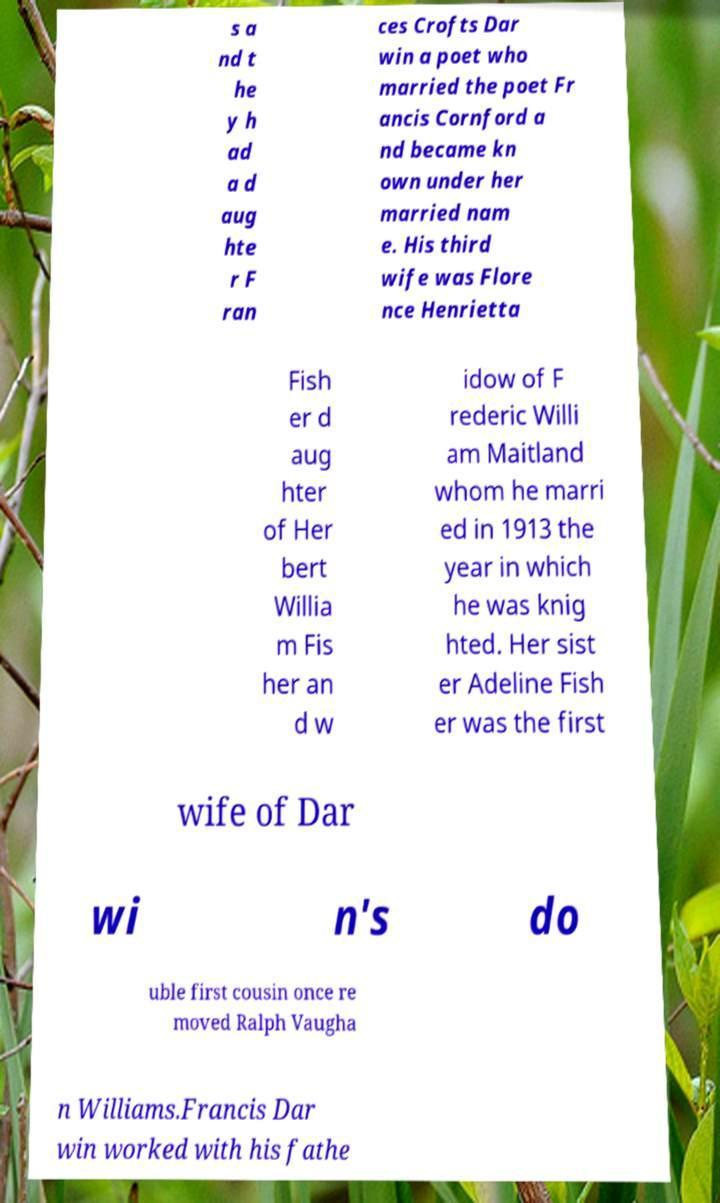For documentation purposes, I need the text within this image transcribed. Could you provide that? s a nd t he y h ad a d aug hte r F ran ces Crofts Dar win a poet who married the poet Fr ancis Cornford a nd became kn own under her married nam e. His third wife was Flore nce Henrietta Fish er d aug hter of Her bert Willia m Fis her an d w idow of F rederic Willi am Maitland whom he marri ed in 1913 the year in which he was knig hted. Her sist er Adeline Fish er was the first wife of Dar wi n's do uble first cousin once re moved Ralph Vaugha n Williams.Francis Dar win worked with his fathe 